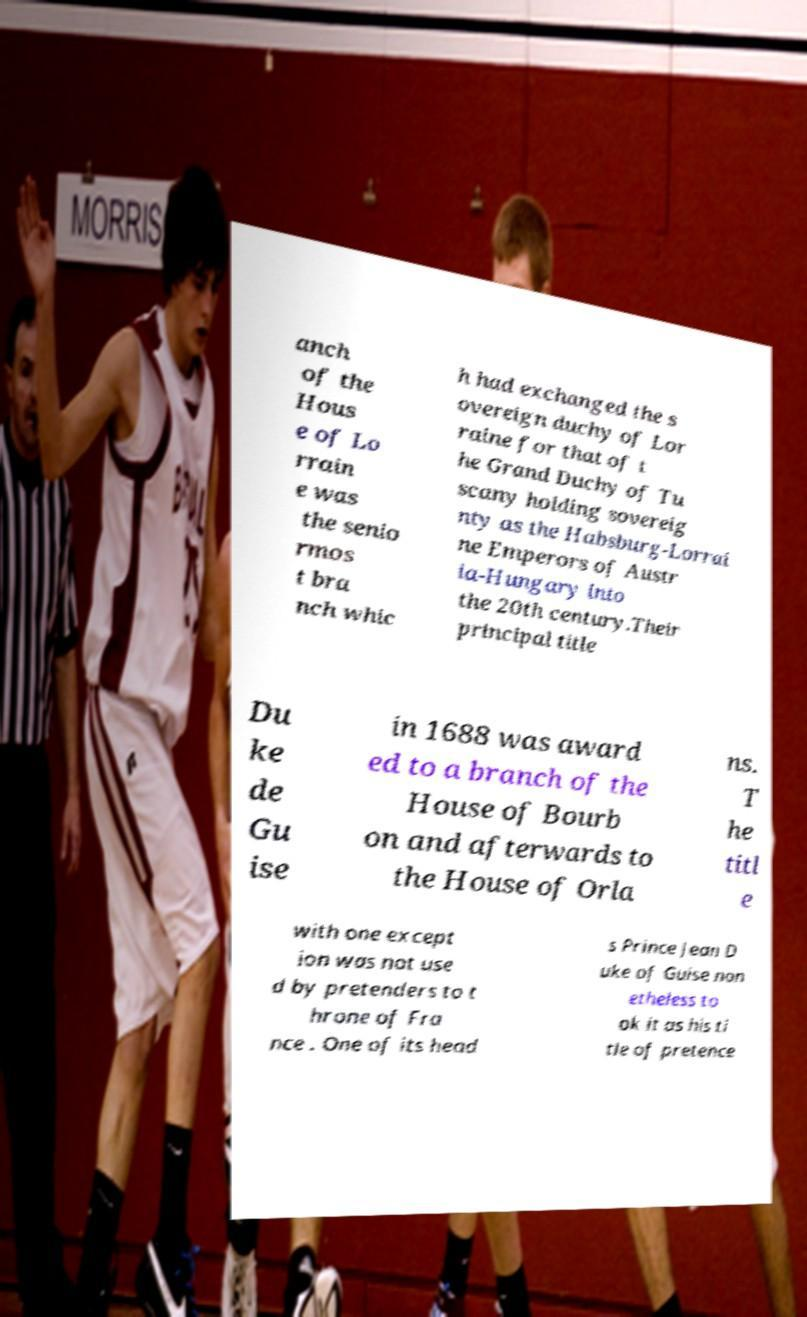Can you read and provide the text displayed in the image?This photo seems to have some interesting text. Can you extract and type it out for me? anch of the Hous e of Lo rrain e was the senio rmos t bra nch whic h had exchanged the s overeign duchy of Lor raine for that of t he Grand Duchy of Tu scany holding sovereig nty as the Habsburg-Lorrai ne Emperors of Austr ia-Hungary into the 20th century.Their principal title Du ke de Gu ise in 1688 was award ed to a branch of the House of Bourb on and afterwards to the House of Orla ns. T he titl e with one except ion was not use d by pretenders to t hrone of Fra nce . One of its head s Prince Jean D uke of Guise non etheless to ok it as his ti tle of pretence 